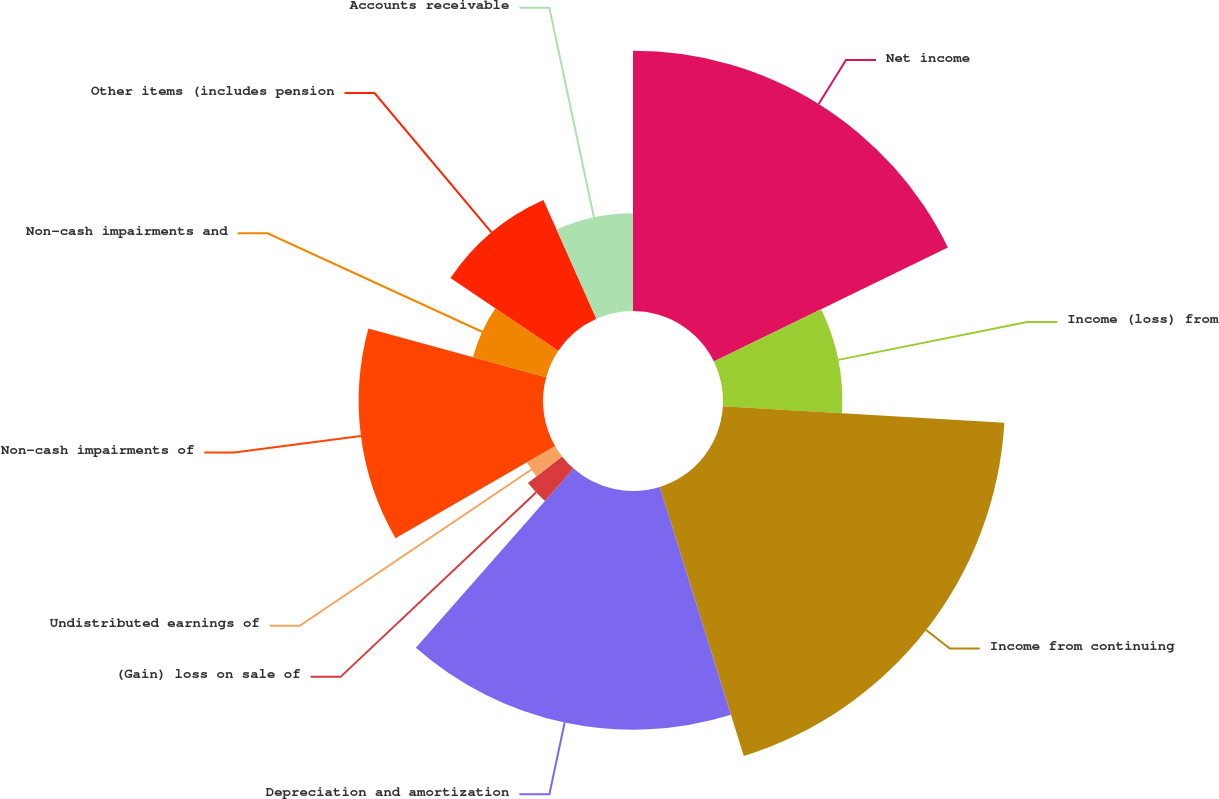<chart> <loc_0><loc_0><loc_500><loc_500><pie_chart><fcel>Net income<fcel>Income (loss) from<fcel>Income from continuing<fcel>Depreciation and amortization<fcel>(Gain) loss on sale of<fcel>Undistributed earnings of<fcel>Non-cash impairments of<fcel>Non-cash impairments and<fcel>Other items (includes pension<fcel>Accounts receivable<nl><fcel>17.78%<fcel>8.15%<fcel>19.26%<fcel>16.3%<fcel>2.96%<fcel>2.22%<fcel>12.59%<fcel>5.19%<fcel>8.89%<fcel>6.67%<nl></chart> 